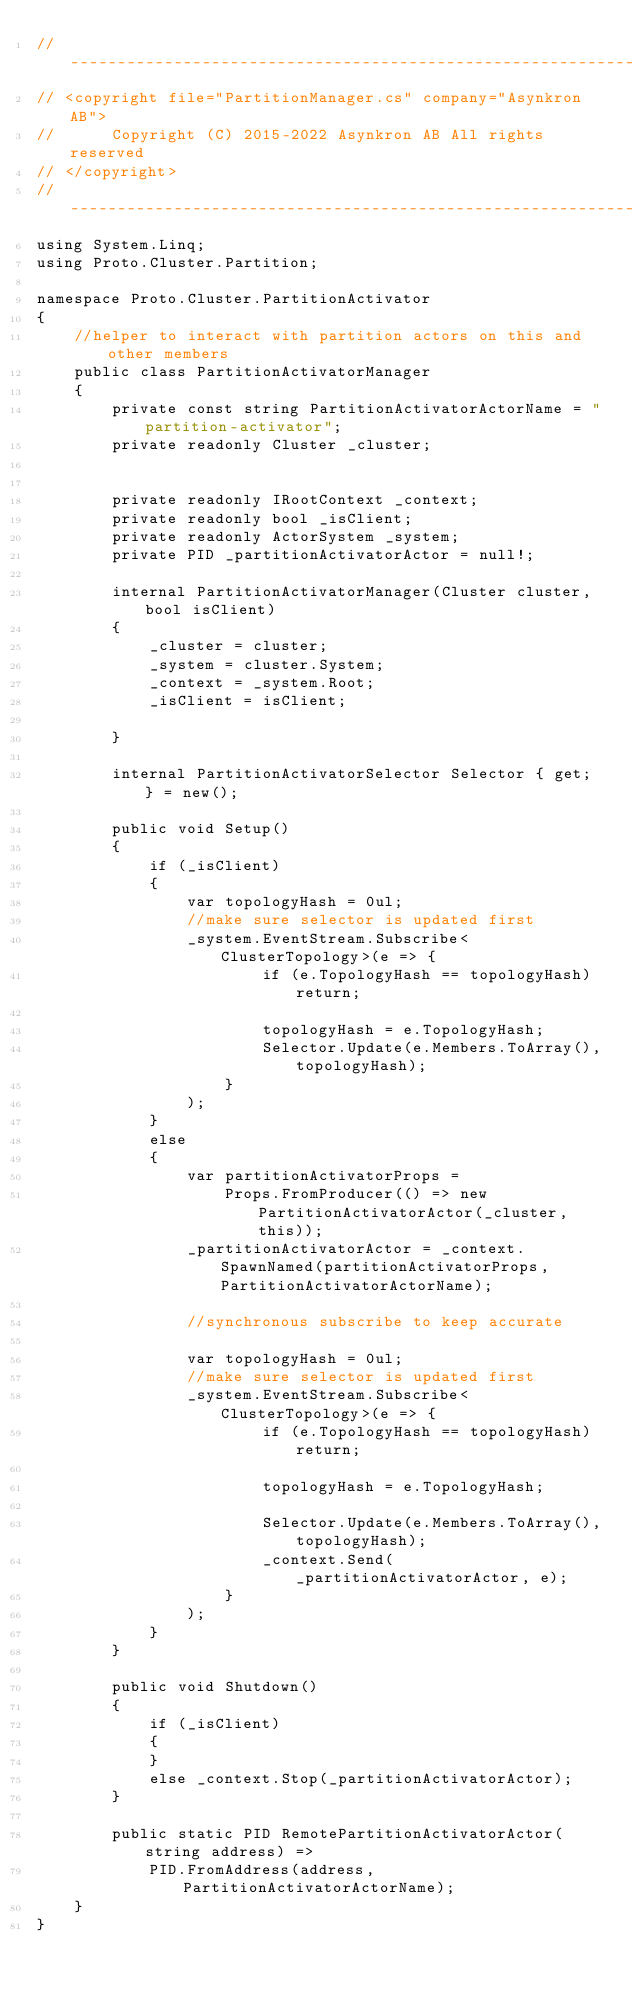<code> <loc_0><loc_0><loc_500><loc_500><_C#_>// -----------------------------------------------------------------------
// <copyright file="PartitionManager.cs" company="Asynkron AB">
//      Copyright (C) 2015-2022 Asynkron AB All rights reserved
// </copyright>
// -----------------------------------------------------------------------
using System.Linq;
using Proto.Cluster.Partition;

namespace Proto.Cluster.PartitionActivator
{
    //helper to interact with partition actors on this and other members
    public class PartitionActivatorManager
    {
        private const string PartitionActivatorActorName = "partition-activator";
        private readonly Cluster _cluster;


        private readonly IRootContext _context;
        private readonly bool _isClient;
        private readonly ActorSystem _system;
        private PID _partitionActivatorActor = null!;

        internal PartitionActivatorManager(Cluster cluster, bool isClient)
        {
            _cluster = cluster;
            _system = cluster.System;
            _context = _system.Root;
            _isClient = isClient;
 
        }

        internal PartitionActivatorSelector Selector { get; } = new();

        public void Setup()
        {
            if (_isClient)
            {
                var topologyHash = 0ul;
                //make sure selector is updated first
                _system.EventStream.Subscribe<ClusterTopology>(e => {
                        if (e.TopologyHash == topologyHash) return;

                        topologyHash = e.TopologyHash;
                        Selector.Update(e.Members.ToArray(),topologyHash);
                    }
                );
            }
            else
            {
                var partitionActivatorProps =
                    Props.FromProducer(() => new PartitionActivatorActor(_cluster, this));
                _partitionActivatorActor = _context.SpawnNamed(partitionActivatorProps, PartitionActivatorActorName);

                //synchronous subscribe to keep accurate

                var topologyHash = 0ul;
                //make sure selector is updated first
                _system.EventStream.Subscribe<ClusterTopology>(e => {
                        if (e.TopologyHash == topologyHash) return;

                        topologyHash = e.TopologyHash;

                        Selector.Update(e.Members.ToArray(),topologyHash);
                        _context.Send(_partitionActivatorActor, e);
                    }
                );
            }
        }

        public void Shutdown()
        {
            if (_isClient)
            {
            }
            else _context.Stop(_partitionActivatorActor);
        }

        public static PID RemotePartitionActivatorActor(string address) =>
            PID.FromAddress(address, PartitionActivatorActorName);
    }
}</code> 